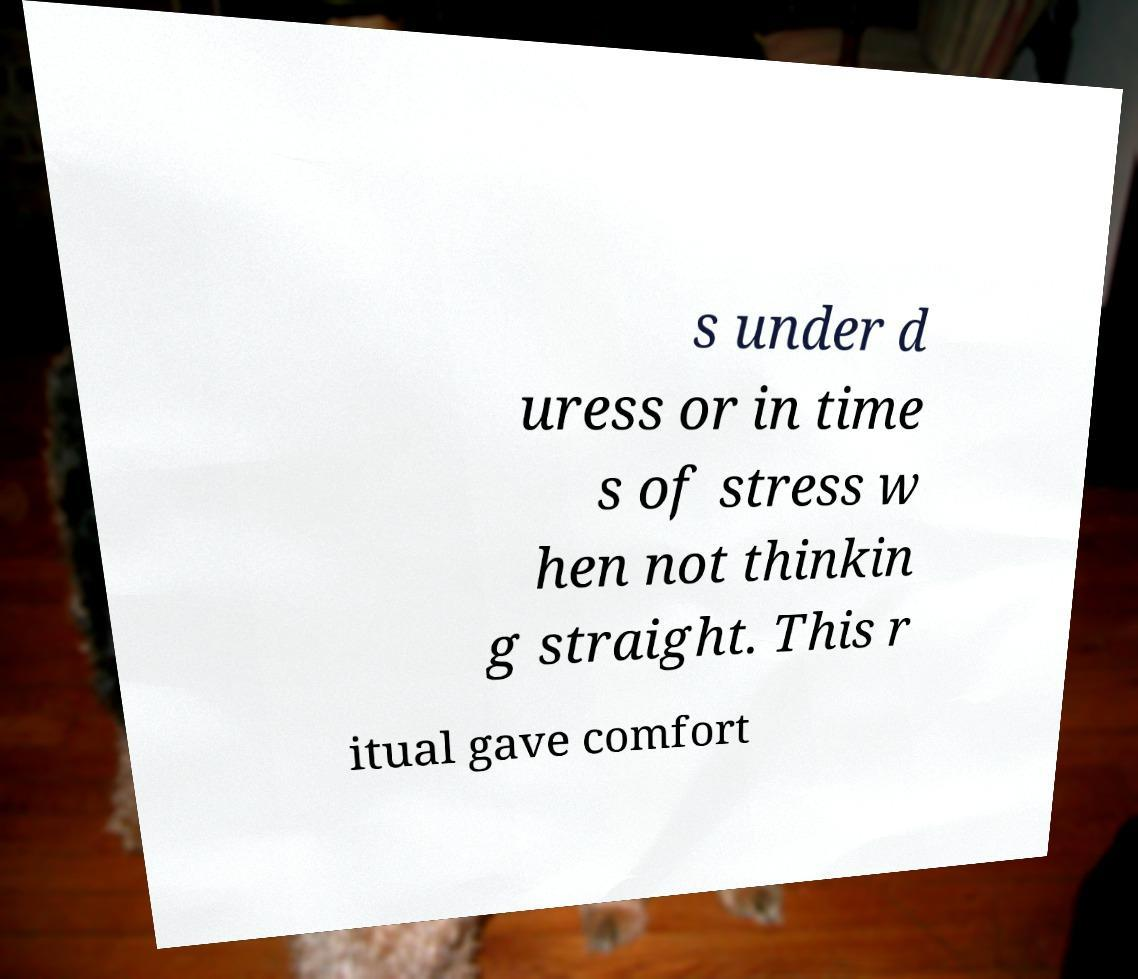Please read and relay the text visible in this image. What does it say? s under d uress or in time s of stress w hen not thinkin g straight. This r itual gave comfort 